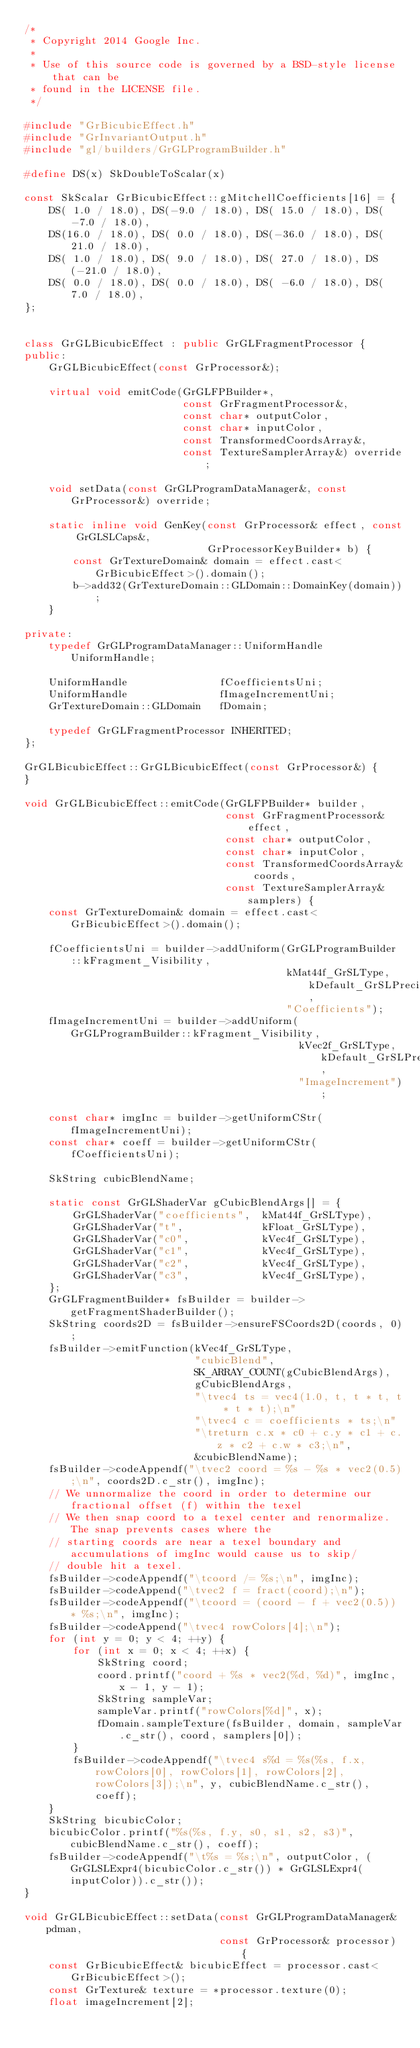Convert code to text. <code><loc_0><loc_0><loc_500><loc_500><_C++_>/*
 * Copyright 2014 Google Inc.
 *
 * Use of this source code is governed by a BSD-style license that can be
 * found in the LICENSE file.
 */

#include "GrBicubicEffect.h"
#include "GrInvariantOutput.h"
#include "gl/builders/GrGLProgramBuilder.h"

#define DS(x) SkDoubleToScalar(x)

const SkScalar GrBicubicEffect::gMitchellCoefficients[16] = {
    DS( 1.0 / 18.0), DS(-9.0 / 18.0), DS( 15.0 / 18.0), DS( -7.0 / 18.0),
    DS(16.0 / 18.0), DS( 0.0 / 18.0), DS(-36.0 / 18.0), DS( 21.0 / 18.0),
    DS( 1.0 / 18.0), DS( 9.0 / 18.0), DS( 27.0 / 18.0), DS(-21.0 / 18.0),
    DS( 0.0 / 18.0), DS( 0.0 / 18.0), DS( -6.0 / 18.0), DS(  7.0 / 18.0),
};


class GrGLBicubicEffect : public GrGLFragmentProcessor {
public:
    GrGLBicubicEffect(const GrProcessor&);

    virtual void emitCode(GrGLFPBuilder*,
                          const GrFragmentProcessor&,
                          const char* outputColor,
                          const char* inputColor,
                          const TransformedCoordsArray&,
                          const TextureSamplerArray&) override;

    void setData(const GrGLProgramDataManager&, const GrProcessor&) override;

    static inline void GenKey(const GrProcessor& effect, const GrGLSLCaps&,
                              GrProcessorKeyBuilder* b) {
        const GrTextureDomain& domain = effect.cast<GrBicubicEffect>().domain();
        b->add32(GrTextureDomain::GLDomain::DomainKey(domain));
    }

private:
    typedef GrGLProgramDataManager::UniformHandle UniformHandle;

    UniformHandle               fCoefficientsUni;
    UniformHandle               fImageIncrementUni;
    GrTextureDomain::GLDomain   fDomain;

    typedef GrGLFragmentProcessor INHERITED;
};

GrGLBicubicEffect::GrGLBicubicEffect(const GrProcessor&) {
}

void GrGLBicubicEffect::emitCode(GrGLFPBuilder* builder,
                                 const GrFragmentProcessor& effect,
                                 const char* outputColor,
                                 const char* inputColor,
                                 const TransformedCoordsArray& coords,
                                 const TextureSamplerArray& samplers) {
    const GrTextureDomain& domain = effect.cast<GrBicubicEffect>().domain();

    fCoefficientsUni = builder->addUniform(GrGLProgramBuilder::kFragment_Visibility,
                                           kMat44f_GrSLType, kDefault_GrSLPrecision,
                                           "Coefficients");
    fImageIncrementUni = builder->addUniform(GrGLProgramBuilder::kFragment_Visibility,
                                             kVec2f_GrSLType, kDefault_GrSLPrecision,
                                             "ImageIncrement");

    const char* imgInc = builder->getUniformCStr(fImageIncrementUni);
    const char* coeff = builder->getUniformCStr(fCoefficientsUni);

    SkString cubicBlendName;

    static const GrGLShaderVar gCubicBlendArgs[] = {
        GrGLShaderVar("coefficients",  kMat44f_GrSLType),
        GrGLShaderVar("t",             kFloat_GrSLType),
        GrGLShaderVar("c0",            kVec4f_GrSLType),
        GrGLShaderVar("c1",            kVec4f_GrSLType),
        GrGLShaderVar("c2",            kVec4f_GrSLType),
        GrGLShaderVar("c3",            kVec4f_GrSLType),
    };
    GrGLFragmentBuilder* fsBuilder = builder->getFragmentShaderBuilder();
    SkString coords2D = fsBuilder->ensureFSCoords2D(coords, 0);
    fsBuilder->emitFunction(kVec4f_GrSLType,
                            "cubicBlend",
                            SK_ARRAY_COUNT(gCubicBlendArgs),
                            gCubicBlendArgs,
                            "\tvec4 ts = vec4(1.0, t, t * t, t * t * t);\n"
                            "\tvec4 c = coefficients * ts;\n"
                            "\treturn c.x * c0 + c.y * c1 + c.z * c2 + c.w * c3;\n",
                            &cubicBlendName);
    fsBuilder->codeAppendf("\tvec2 coord = %s - %s * vec2(0.5);\n", coords2D.c_str(), imgInc);
    // We unnormalize the coord in order to determine our fractional offset (f) within the texel
    // We then snap coord to a texel center and renormalize. The snap prevents cases where the
    // starting coords are near a texel boundary and accumulations of imgInc would cause us to skip/
    // double hit a texel.
    fsBuilder->codeAppendf("\tcoord /= %s;\n", imgInc);
    fsBuilder->codeAppend("\tvec2 f = fract(coord);\n");
    fsBuilder->codeAppendf("\tcoord = (coord - f + vec2(0.5)) * %s;\n", imgInc);
    fsBuilder->codeAppend("\tvec4 rowColors[4];\n");
    for (int y = 0; y < 4; ++y) {
        for (int x = 0; x < 4; ++x) {
            SkString coord;
            coord.printf("coord + %s * vec2(%d, %d)", imgInc, x - 1, y - 1);
            SkString sampleVar;
            sampleVar.printf("rowColors[%d]", x);
            fDomain.sampleTexture(fsBuilder, domain, sampleVar.c_str(), coord, samplers[0]);
        }
        fsBuilder->codeAppendf("\tvec4 s%d = %s(%s, f.x, rowColors[0], rowColors[1], rowColors[2], rowColors[3]);\n", y, cubicBlendName.c_str(), coeff);
    }
    SkString bicubicColor;
    bicubicColor.printf("%s(%s, f.y, s0, s1, s2, s3)", cubicBlendName.c_str(), coeff);
    fsBuilder->codeAppendf("\t%s = %s;\n", outputColor, (GrGLSLExpr4(bicubicColor.c_str()) * GrGLSLExpr4(inputColor)).c_str());
}

void GrGLBicubicEffect::setData(const GrGLProgramDataManager& pdman,
                                const GrProcessor& processor) {
    const GrBicubicEffect& bicubicEffect = processor.cast<GrBicubicEffect>();
    const GrTexture& texture = *processor.texture(0);
    float imageIncrement[2];</code> 